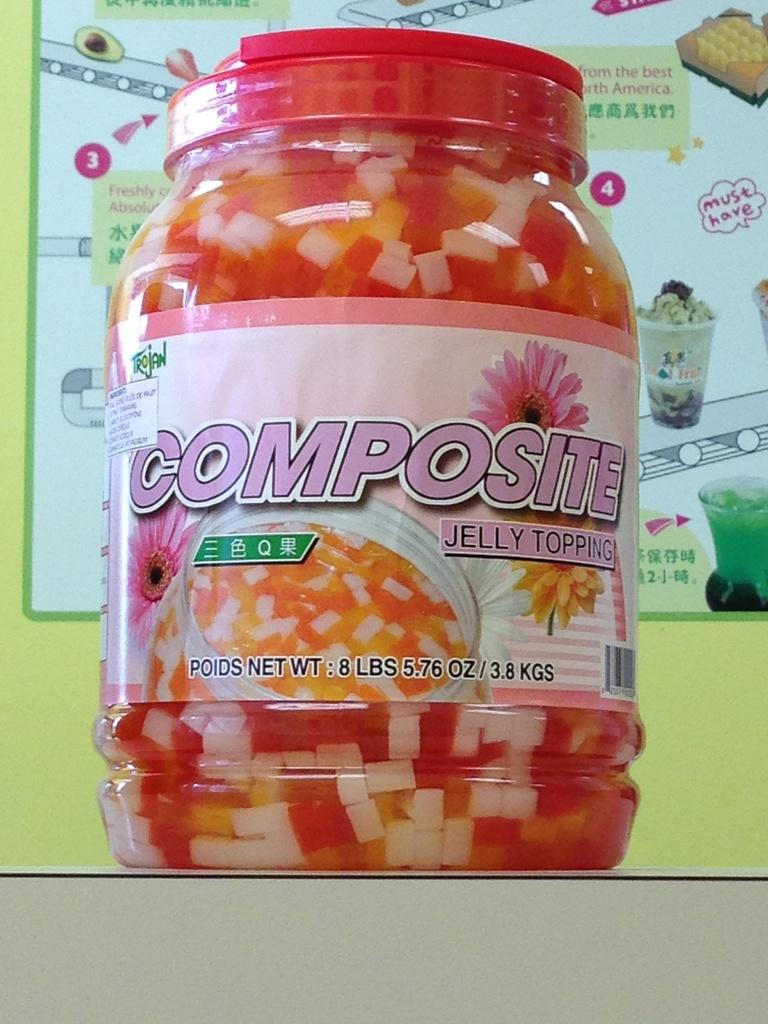What is the main object in the image? There is a container with a lid in the image. What is inside the container? There is food inside the container. Where is the container located? The container is placed on a surface. What type of lead can be seen in the image? There is no lead present in the image. Is there a volleyball being played in the image? There is no volleyball or any indication of a game being played in the image. 